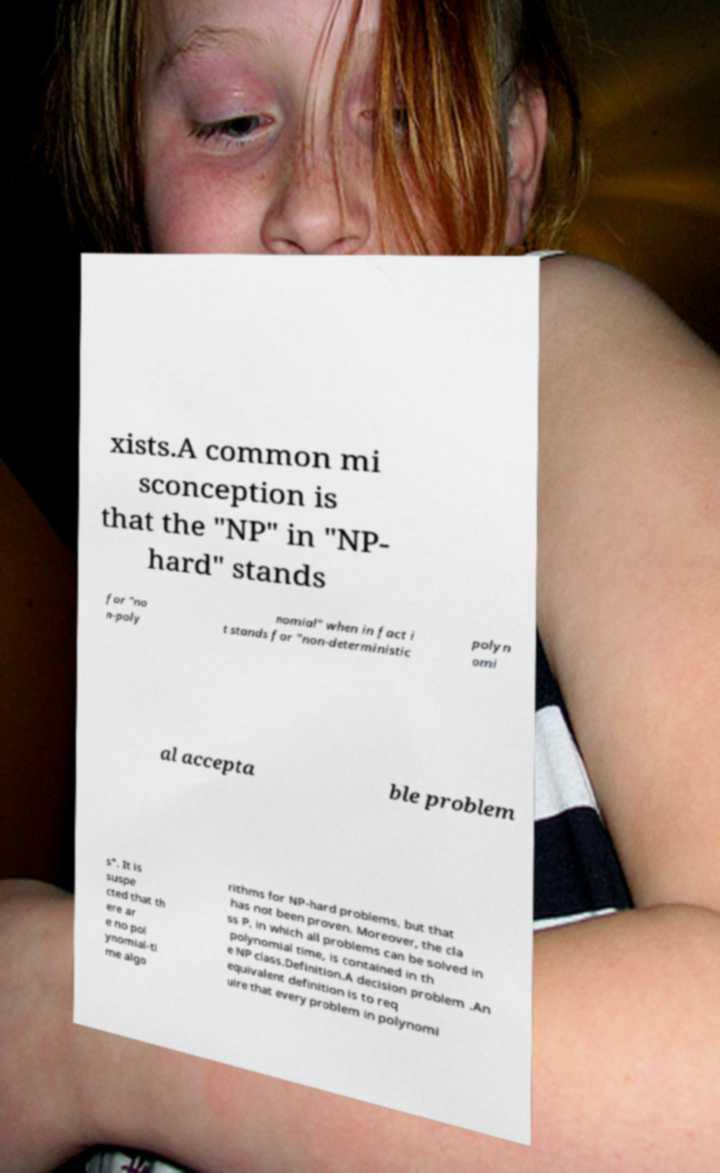What messages or text are displayed in this image? I need them in a readable, typed format. xists.A common mi sconception is that the "NP" in "NP- hard" stands for "no n-poly nomial" when in fact i t stands for "non-deterministic polyn omi al accepta ble problem s". It is suspe cted that th ere ar e no pol ynomial-ti me algo rithms for NP-hard problems, but that has not been proven. Moreover, the cla ss P, in which all problems can be solved in polynomial time, is contained in th e NP class.Definition.A decision problem .An equivalent definition is to req uire that every problem in polynomi 